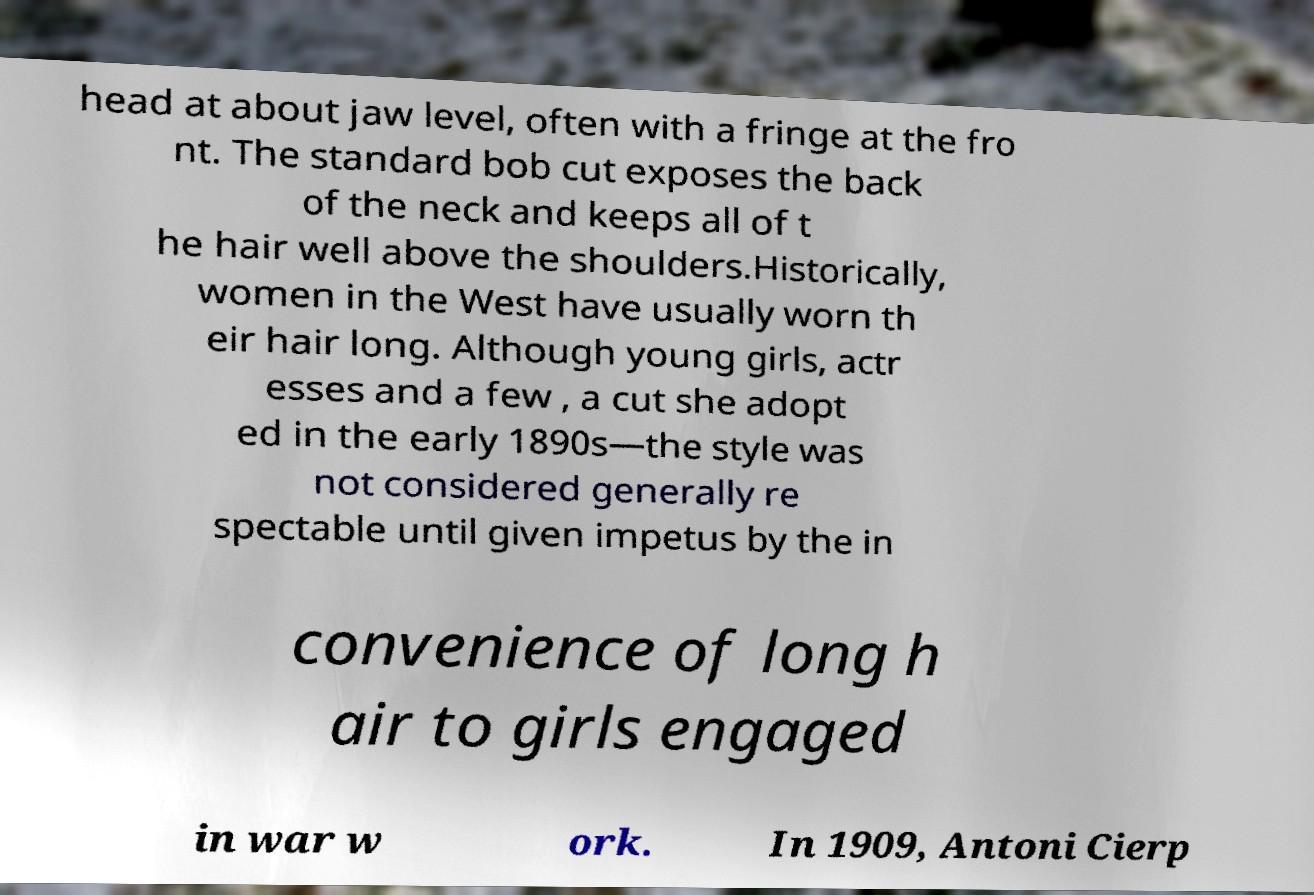For documentation purposes, I need the text within this image transcribed. Could you provide that? head at about jaw level, often with a fringe at the fro nt. The standard bob cut exposes the back of the neck and keeps all of t he hair well above the shoulders.Historically, women in the West have usually worn th eir hair long. Although young girls, actr esses and a few , a cut she adopt ed in the early 1890s—the style was not considered generally re spectable until given impetus by the in convenience of long h air to girls engaged in war w ork. In 1909, Antoni Cierp 